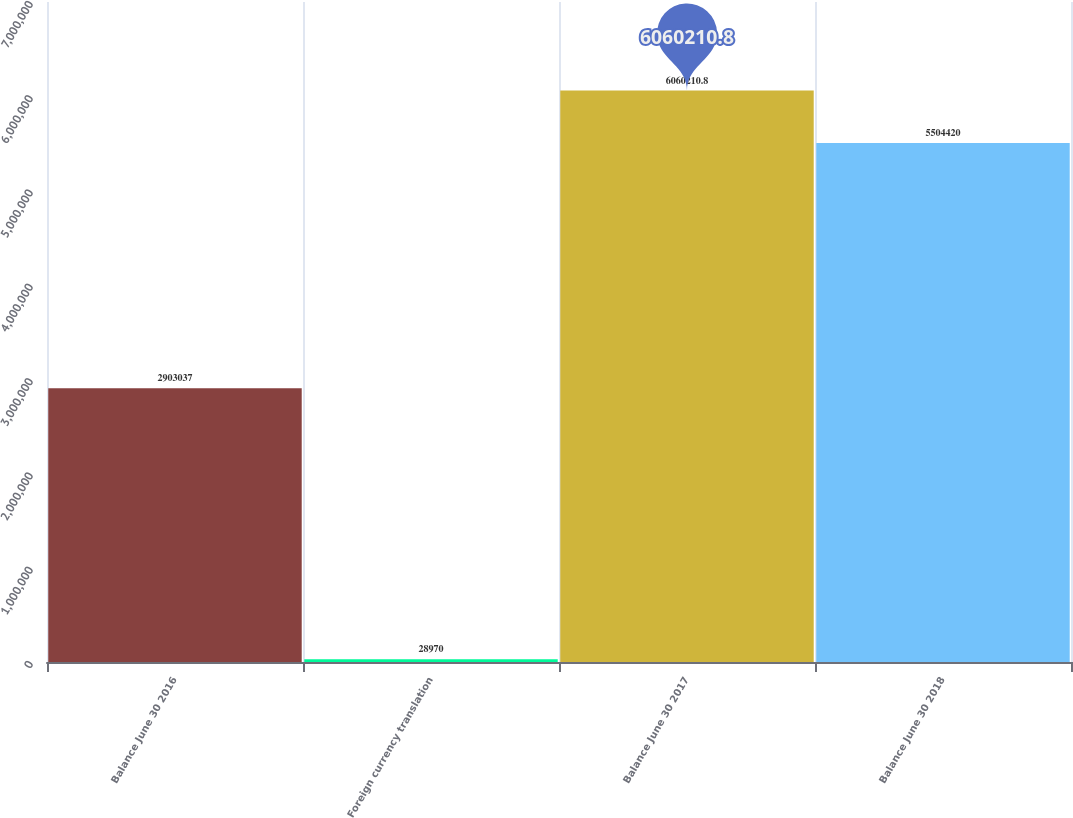Convert chart. <chart><loc_0><loc_0><loc_500><loc_500><bar_chart><fcel>Balance June 30 2016<fcel>Foreign currency translation<fcel>Balance June 30 2017<fcel>Balance June 30 2018<nl><fcel>2.90304e+06<fcel>28970<fcel>6.06021e+06<fcel>5.50442e+06<nl></chart> 